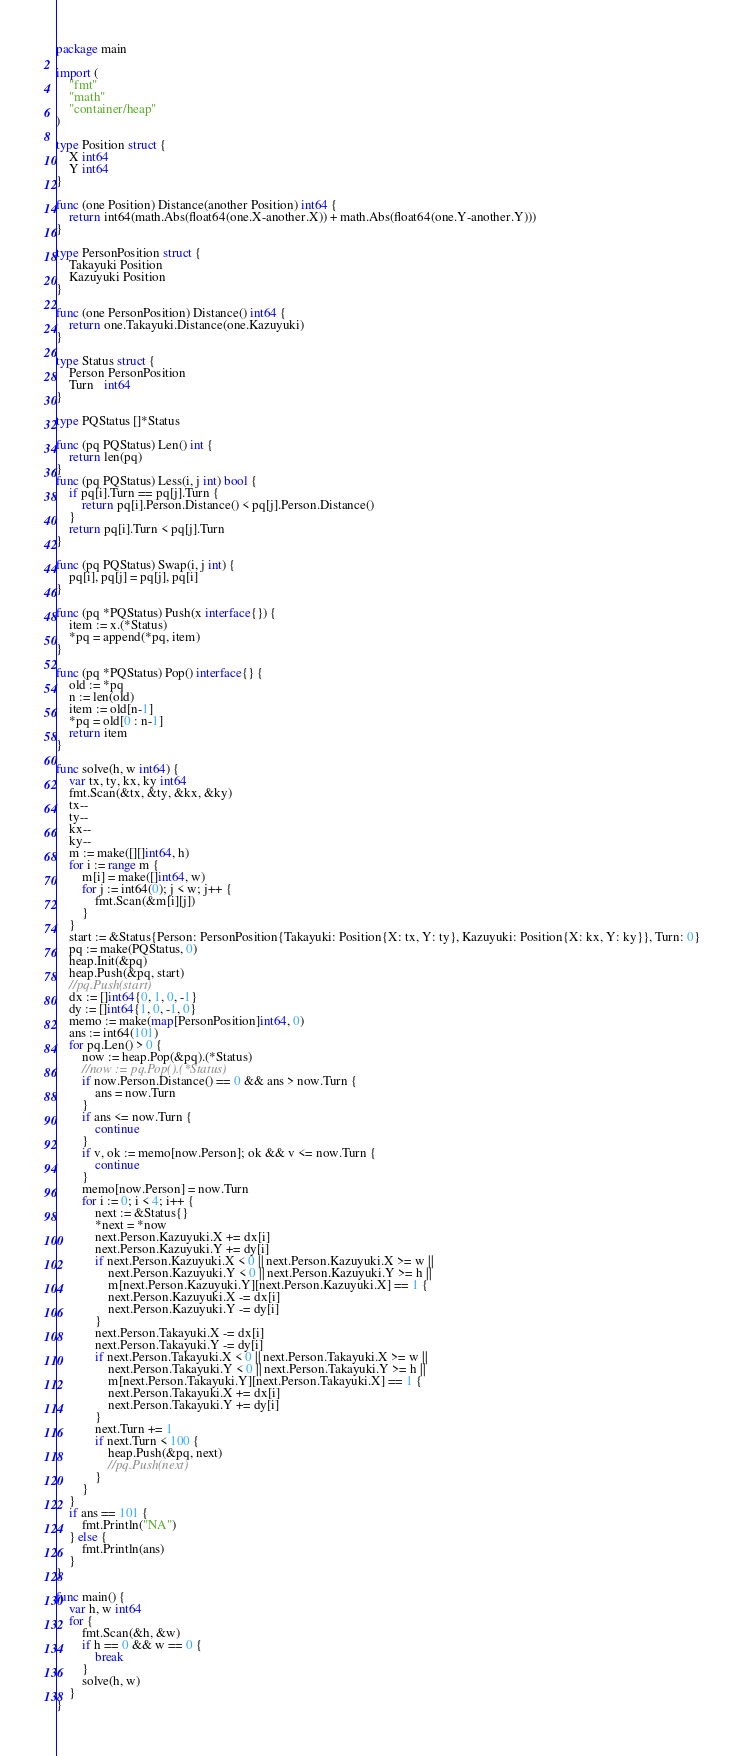Convert code to text. <code><loc_0><loc_0><loc_500><loc_500><_Go_>package main

import (
	"fmt"
	"math"
	"container/heap"
)

type Position struct {
	X int64
	Y int64
}

func (one Position) Distance(another Position) int64 {
	return int64(math.Abs(float64(one.X-another.X)) + math.Abs(float64(one.Y-another.Y)))
}

type PersonPosition struct {
	Takayuki Position
	Kazuyuki Position
}

func (one PersonPosition) Distance() int64 {
	return one.Takayuki.Distance(one.Kazuyuki)
}

type Status struct {
	Person PersonPosition
	Turn   int64
}

type PQStatus []*Status

func (pq PQStatus) Len() int {
	return len(pq)
}
func (pq PQStatus) Less(i, j int) bool {
	if pq[i].Turn == pq[j].Turn {
		return pq[i].Person.Distance() < pq[j].Person.Distance()
	}
	return pq[i].Turn < pq[j].Turn
}

func (pq PQStatus) Swap(i, j int) {
	pq[i], pq[j] = pq[j], pq[i]
}

func (pq *PQStatus) Push(x interface{}) {
	item := x.(*Status)
	*pq = append(*pq, item)
}

func (pq *PQStatus) Pop() interface{} {
	old := *pq
	n := len(old)
	item := old[n-1]
	*pq = old[0 : n-1]
	return item
}

func solve(h, w int64) {
	var tx, ty, kx, ky int64
	fmt.Scan(&tx, &ty, &kx, &ky)
	tx--
	ty--
	kx--
	ky--
	m := make([][]int64, h)
	for i := range m {
		m[i] = make([]int64, w)
		for j := int64(0); j < w; j++ {
			fmt.Scan(&m[i][j])
		}
	}
	start := &Status{Person: PersonPosition{Takayuki: Position{X: tx, Y: ty}, Kazuyuki: Position{X: kx, Y: ky}}, Turn: 0}
	pq := make(PQStatus, 0)
	heap.Init(&pq)
	heap.Push(&pq, start)
	//pq.Push(start)
	dx := []int64{0, 1, 0, -1}
	dy := []int64{1, 0, -1, 0}
	memo := make(map[PersonPosition]int64, 0)
	ans := int64(101)
	for pq.Len() > 0 {
		now := heap.Pop(&pq).(*Status)
		//now := pq.Pop().(*Status)
		if now.Person.Distance() == 0 && ans > now.Turn {
			ans = now.Turn
		}
		if ans <= now.Turn {
			continue
		}
		if v, ok := memo[now.Person]; ok && v <= now.Turn {
			continue
		}
		memo[now.Person] = now.Turn
		for i := 0; i < 4; i++ {
			next := &Status{}
			*next = *now
			next.Person.Kazuyuki.X += dx[i]
			next.Person.Kazuyuki.Y += dy[i]
			if next.Person.Kazuyuki.X < 0 || next.Person.Kazuyuki.X >= w ||
				next.Person.Kazuyuki.Y < 0 || next.Person.Kazuyuki.Y >= h ||
				m[next.Person.Kazuyuki.Y][next.Person.Kazuyuki.X] == 1 {
				next.Person.Kazuyuki.X -= dx[i]
				next.Person.Kazuyuki.Y -= dy[i]
			}
			next.Person.Takayuki.X -= dx[i]
			next.Person.Takayuki.Y -= dy[i]
			if next.Person.Takayuki.X < 0 || next.Person.Takayuki.X >= w ||
				next.Person.Takayuki.Y < 0 || next.Person.Takayuki.Y >= h ||
				m[next.Person.Takayuki.Y][next.Person.Takayuki.X] == 1 {
				next.Person.Takayuki.X += dx[i]
				next.Person.Takayuki.Y += dy[i]
			}
			next.Turn += 1
			if next.Turn < 100 {
				heap.Push(&pq, next)
				//pq.Push(next)
			}
		}
	}
	if ans == 101 {
		fmt.Println("NA")
	} else {
		fmt.Println(ans)
	}
}

func main() {
	var h, w int64
	for {
		fmt.Scan(&h, &w)
		if h == 0 && w == 0 {
			break
		}
		solve(h, w)
	}
}

</code> 